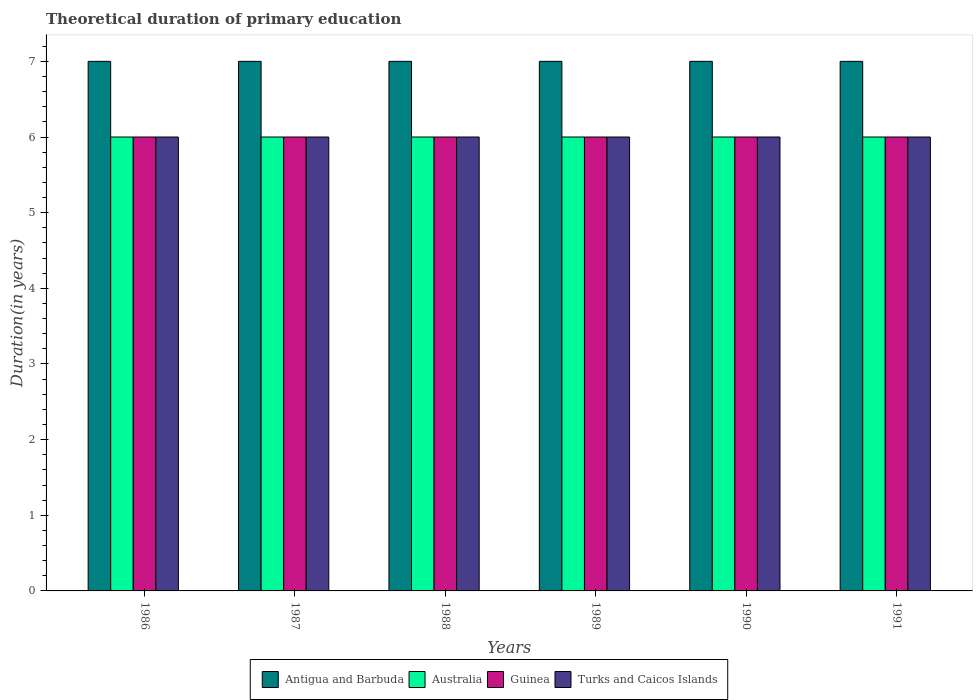How many groups of bars are there?
Ensure brevity in your answer.  6. How many bars are there on the 3rd tick from the left?
Your answer should be very brief. 4. How many bars are there on the 4th tick from the right?
Offer a very short reply. 4. What is the total theoretical duration of primary education in Turks and Caicos Islands in 1987?
Provide a short and direct response. 6. In which year was the total theoretical duration of primary education in Australia maximum?
Your answer should be compact. 1986. What is the total total theoretical duration of primary education in Turks and Caicos Islands in the graph?
Offer a very short reply. 36. What is the difference between the total theoretical duration of primary education in Antigua and Barbuda in 1987 and the total theoretical duration of primary education in Guinea in 1990?
Provide a short and direct response. 1. What is the average total theoretical duration of primary education in Guinea per year?
Your answer should be compact. 6. In the year 1990, what is the difference between the total theoretical duration of primary education in Australia and total theoretical duration of primary education in Turks and Caicos Islands?
Keep it short and to the point. 0. Is the total theoretical duration of primary education in Australia in 1988 less than that in 1990?
Provide a succinct answer. No. What is the difference between the highest and the second highest total theoretical duration of primary education in Guinea?
Keep it short and to the point. 0. What does the 4th bar from the left in 1991 represents?
Provide a short and direct response. Turks and Caicos Islands. What does the 4th bar from the right in 1988 represents?
Make the answer very short. Antigua and Barbuda. Is it the case that in every year, the sum of the total theoretical duration of primary education in Turks and Caicos Islands and total theoretical duration of primary education in Australia is greater than the total theoretical duration of primary education in Antigua and Barbuda?
Make the answer very short. Yes. How many bars are there?
Make the answer very short. 24. Does the graph contain any zero values?
Your response must be concise. No. Does the graph contain grids?
Offer a terse response. No. Where does the legend appear in the graph?
Make the answer very short. Bottom center. How are the legend labels stacked?
Offer a terse response. Horizontal. What is the title of the graph?
Your response must be concise. Theoretical duration of primary education. Does "Timor-Leste" appear as one of the legend labels in the graph?
Keep it short and to the point. No. What is the label or title of the Y-axis?
Offer a very short reply. Duration(in years). What is the Duration(in years) in Australia in 1986?
Provide a short and direct response. 6. What is the Duration(in years) in Antigua and Barbuda in 1987?
Make the answer very short. 7. What is the Duration(in years) in Australia in 1987?
Your answer should be compact. 6. What is the Duration(in years) of Antigua and Barbuda in 1989?
Your response must be concise. 7. What is the Duration(in years) of Australia in 1989?
Offer a terse response. 6. What is the Duration(in years) of Antigua and Barbuda in 1991?
Make the answer very short. 7. What is the Duration(in years) of Guinea in 1991?
Your answer should be compact. 6. What is the Duration(in years) of Turks and Caicos Islands in 1991?
Provide a succinct answer. 6. Across all years, what is the maximum Duration(in years) of Antigua and Barbuda?
Offer a terse response. 7. Across all years, what is the maximum Duration(in years) of Guinea?
Keep it short and to the point. 6. What is the total Duration(in years) of Antigua and Barbuda in the graph?
Give a very brief answer. 42. What is the total Duration(in years) of Guinea in the graph?
Make the answer very short. 36. What is the difference between the Duration(in years) of Antigua and Barbuda in 1986 and that in 1987?
Your answer should be compact. 0. What is the difference between the Duration(in years) in Australia in 1986 and that in 1987?
Give a very brief answer. 0. What is the difference between the Duration(in years) in Guinea in 1986 and that in 1987?
Make the answer very short. 0. What is the difference between the Duration(in years) in Antigua and Barbuda in 1986 and that in 1988?
Your response must be concise. 0. What is the difference between the Duration(in years) in Australia in 1986 and that in 1988?
Your response must be concise. 0. What is the difference between the Duration(in years) of Guinea in 1986 and that in 1988?
Provide a short and direct response. 0. What is the difference between the Duration(in years) of Turks and Caicos Islands in 1986 and that in 1988?
Your answer should be compact. 0. What is the difference between the Duration(in years) of Antigua and Barbuda in 1986 and that in 1989?
Your response must be concise. 0. What is the difference between the Duration(in years) in Australia in 1986 and that in 1989?
Provide a succinct answer. 0. What is the difference between the Duration(in years) of Antigua and Barbuda in 1986 and that in 1990?
Ensure brevity in your answer.  0. What is the difference between the Duration(in years) of Guinea in 1986 and that in 1991?
Offer a very short reply. 0. What is the difference between the Duration(in years) in Guinea in 1987 and that in 1988?
Your answer should be compact. 0. What is the difference between the Duration(in years) of Australia in 1987 and that in 1989?
Your answer should be very brief. 0. What is the difference between the Duration(in years) of Guinea in 1987 and that in 1989?
Make the answer very short. 0. What is the difference between the Duration(in years) in Australia in 1987 and that in 1990?
Make the answer very short. 0. What is the difference between the Duration(in years) of Turks and Caicos Islands in 1987 and that in 1990?
Your answer should be very brief. 0. What is the difference between the Duration(in years) in Australia in 1987 and that in 1991?
Your answer should be very brief. 0. What is the difference between the Duration(in years) of Australia in 1988 and that in 1989?
Make the answer very short. 0. What is the difference between the Duration(in years) of Antigua and Barbuda in 1988 and that in 1990?
Provide a short and direct response. 0. What is the difference between the Duration(in years) in Australia in 1988 and that in 1990?
Offer a terse response. 0. What is the difference between the Duration(in years) in Turks and Caicos Islands in 1988 and that in 1990?
Offer a terse response. 0. What is the difference between the Duration(in years) of Antigua and Barbuda in 1988 and that in 1991?
Your answer should be very brief. 0. What is the difference between the Duration(in years) of Guinea in 1988 and that in 1991?
Your answer should be very brief. 0. What is the difference between the Duration(in years) of Antigua and Barbuda in 1989 and that in 1990?
Your answer should be compact. 0. What is the difference between the Duration(in years) in Guinea in 1989 and that in 1990?
Your answer should be very brief. 0. What is the difference between the Duration(in years) in Antigua and Barbuda in 1989 and that in 1991?
Offer a terse response. 0. What is the difference between the Duration(in years) of Guinea in 1989 and that in 1991?
Your answer should be compact. 0. What is the difference between the Duration(in years) in Turks and Caicos Islands in 1989 and that in 1991?
Provide a succinct answer. 0. What is the difference between the Duration(in years) of Australia in 1990 and that in 1991?
Offer a very short reply. 0. What is the difference between the Duration(in years) of Turks and Caicos Islands in 1990 and that in 1991?
Your answer should be very brief. 0. What is the difference between the Duration(in years) of Australia in 1986 and the Duration(in years) of Guinea in 1987?
Keep it short and to the point. 0. What is the difference between the Duration(in years) of Australia in 1986 and the Duration(in years) of Turks and Caicos Islands in 1987?
Provide a short and direct response. 0. What is the difference between the Duration(in years) of Antigua and Barbuda in 1986 and the Duration(in years) of Guinea in 1988?
Make the answer very short. 1. What is the difference between the Duration(in years) of Antigua and Barbuda in 1986 and the Duration(in years) of Turks and Caicos Islands in 1988?
Your response must be concise. 1. What is the difference between the Duration(in years) in Guinea in 1986 and the Duration(in years) in Turks and Caicos Islands in 1988?
Ensure brevity in your answer.  0. What is the difference between the Duration(in years) of Antigua and Barbuda in 1986 and the Duration(in years) of Turks and Caicos Islands in 1989?
Your answer should be compact. 1. What is the difference between the Duration(in years) in Australia in 1986 and the Duration(in years) in Guinea in 1989?
Give a very brief answer. 0. What is the difference between the Duration(in years) in Australia in 1986 and the Duration(in years) in Guinea in 1990?
Provide a short and direct response. 0. What is the difference between the Duration(in years) in Australia in 1986 and the Duration(in years) in Turks and Caicos Islands in 1990?
Offer a terse response. 0. What is the difference between the Duration(in years) in Antigua and Barbuda in 1986 and the Duration(in years) in Turks and Caicos Islands in 1991?
Provide a short and direct response. 1. What is the difference between the Duration(in years) of Australia in 1986 and the Duration(in years) of Turks and Caicos Islands in 1991?
Provide a short and direct response. 0. What is the difference between the Duration(in years) of Guinea in 1986 and the Duration(in years) of Turks and Caicos Islands in 1991?
Keep it short and to the point. 0. What is the difference between the Duration(in years) in Antigua and Barbuda in 1987 and the Duration(in years) in Turks and Caicos Islands in 1988?
Your response must be concise. 1. What is the difference between the Duration(in years) of Australia in 1987 and the Duration(in years) of Turks and Caicos Islands in 1988?
Keep it short and to the point. 0. What is the difference between the Duration(in years) in Guinea in 1987 and the Duration(in years) in Turks and Caicos Islands in 1988?
Give a very brief answer. 0. What is the difference between the Duration(in years) of Antigua and Barbuda in 1987 and the Duration(in years) of Australia in 1989?
Your answer should be compact. 1. What is the difference between the Duration(in years) in Antigua and Barbuda in 1987 and the Duration(in years) in Turks and Caicos Islands in 1989?
Your answer should be compact. 1. What is the difference between the Duration(in years) of Australia in 1987 and the Duration(in years) of Guinea in 1989?
Offer a terse response. 0. What is the difference between the Duration(in years) in Guinea in 1987 and the Duration(in years) in Turks and Caicos Islands in 1989?
Provide a succinct answer. 0. What is the difference between the Duration(in years) in Antigua and Barbuda in 1987 and the Duration(in years) in Guinea in 1990?
Your answer should be compact. 1. What is the difference between the Duration(in years) in Guinea in 1987 and the Duration(in years) in Turks and Caicos Islands in 1990?
Your answer should be compact. 0. What is the difference between the Duration(in years) in Antigua and Barbuda in 1987 and the Duration(in years) in Australia in 1991?
Ensure brevity in your answer.  1. What is the difference between the Duration(in years) in Antigua and Barbuda in 1987 and the Duration(in years) in Guinea in 1991?
Keep it short and to the point. 1. What is the difference between the Duration(in years) of Antigua and Barbuda in 1987 and the Duration(in years) of Turks and Caicos Islands in 1991?
Your answer should be very brief. 1. What is the difference between the Duration(in years) of Australia in 1987 and the Duration(in years) of Turks and Caicos Islands in 1991?
Offer a very short reply. 0. What is the difference between the Duration(in years) in Guinea in 1987 and the Duration(in years) in Turks and Caicos Islands in 1991?
Your answer should be very brief. 0. What is the difference between the Duration(in years) of Antigua and Barbuda in 1988 and the Duration(in years) of Guinea in 1989?
Ensure brevity in your answer.  1. What is the difference between the Duration(in years) in Australia in 1988 and the Duration(in years) in Turks and Caicos Islands in 1989?
Make the answer very short. 0. What is the difference between the Duration(in years) in Guinea in 1988 and the Duration(in years) in Turks and Caicos Islands in 1989?
Offer a very short reply. 0. What is the difference between the Duration(in years) in Antigua and Barbuda in 1988 and the Duration(in years) in Turks and Caicos Islands in 1990?
Keep it short and to the point. 1. What is the difference between the Duration(in years) of Australia in 1988 and the Duration(in years) of Guinea in 1990?
Your response must be concise. 0. What is the difference between the Duration(in years) of Australia in 1988 and the Duration(in years) of Turks and Caicos Islands in 1990?
Give a very brief answer. 0. What is the difference between the Duration(in years) in Antigua and Barbuda in 1988 and the Duration(in years) in Australia in 1991?
Give a very brief answer. 1. What is the difference between the Duration(in years) of Antigua and Barbuda in 1988 and the Duration(in years) of Guinea in 1991?
Provide a succinct answer. 1. What is the difference between the Duration(in years) in Australia in 1988 and the Duration(in years) in Turks and Caicos Islands in 1991?
Your response must be concise. 0. What is the difference between the Duration(in years) of Antigua and Barbuda in 1989 and the Duration(in years) of Turks and Caicos Islands in 1990?
Make the answer very short. 1. What is the difference between the Duration(in years) in Australia in 1989 and the Duration(in years) in Guinea in 1990?
Provide a short and direct response. 0. What is the difference between the Duration(in years) in Antigua and Barbuda in 1989 and the Duration(in years) in Guinea in 1991?
Provide a succinct answer. 1. What is the difference between the Duration(in years) in Australia in 1989 and the Duration(in years) in Guinea in 1991?
Offer a terse response. 0. What is the difference between the Duration(in years) in Guinea in 1989 and the Duration(in years) in Turks and Caicos Islands in 1991?
Make the answer very short. 0. What is the difference between the Duration(in years) in Antigua and Barbuda in 1990 and the Duration(in years) in Turks and Caicos Islands in 1991?
Keep it short and to the point. 1. What is the difference between the Duration(in years) in Australia in 1990 and the Duration(in years) in Guinea in 1991?
Provide a short and direct response. 0. What is the difference between the Duration(in years) of Guinea in 1990 and the Duration(in years) of Turks and Caicos Islands in 1991?
Provide a short and direct response. 0. What is the average Duration(in years) in Antigua and Barbuda per year?
Offer a terse response. 7. What is the average Duration(in years) in Australia per year?
Offer a very short reply. 6. What is the average Duration(in years) in Guinea per year?
Keep it short and to the point. 6. What is the average Duration(in years) of Turks and Caicos Islands per year?
Provide a short and direct response. 6. In the year 1986, what is the difference between the Duration(in years) in Antigua and Barbuda and Duration(in years) in Australia?
Offer a terse response. 1. In the year 1986, what is the difference between the Duration(in years) of Antigua and Barbuda and Duration(in years) of Guinea?
Keep it short and to the point. 1. In the year 1986, what is the difference between the Duration(in years) in Antigua and Barbuda and Duration(in years) in Turks and Caicos Islands?
Give a very brief answer. 1. In the year 1987, what is the difference between the Duration(in years) of Antigua and Barbuda and Duration(in years) of Guinea?
Ensure brevity in your answer.  1. In the year 1987, what is the difference between the Duration(in years) of Australia and Duration(in years) of Guinea?
Your response must be concise. 0. In the year 1987, what is the difference between the Duration(in years) of Guinea and Duration(in years) of Turks and Caicos Islands?
Make the answer very short. 0. In the year 1988, what is the difference between the Duration(in years) of Antigua and Barbuda and Duration(in years) of Turks and Caicos Islands?
Your answer should be compact. 1. In the year 1989, what is the difference between the Duration(in years) in Antigua and Barbuda and Duration(in years) in Guinea?
Ensure brevity in your answer.  1. In the year 1989, what is the difference between the Duration(in years) in Australia and Duration(in years) in Turks and Caicos Islands?
Offer a terse response. 0. In the year 1989, what is the difference between the Duration(in years) in Guinea and Duration(in years) in Turks and Caicos Islands?
Ensure brevity in your answer.  0. In the year 1990, what is the difference between the Duration(in years) of Antigua and Barbuda and Duration(in years) of Australia?
Your response must be concise. 1. In the year 1990, what is the difference between the Duration(in years) in Antigua and Barbuda and Duration(in years) in Guinea?
Provide a succinct answer. 1. In the year 1990, what is the difference between the Duration(in years) in Australia and Duration(in years) in Guinea?
Your answer should be compact. 0. In the year 1990, what is the difference between the Duration(in years) of Australia and Duration(in years) of Turks and Caicos Islands?
Give a very brief answer. 0. In the year 1991, what is the difference between the Duration(in years) of Australia and Duration(in years) of Turks and Caicos Islands?
Keep it short and to the point. 0. What is the ratio of the Duration(in years) of Australia in 1986 to that in 1987?
Your answer should be very brief. 1. What is the ratio of the Duration(in years) of Guinea in 1986 to that in 1987?
Offer a very short reply. 1. What is the ratio of the Duration(in years) of Turks and Caicos Islands in 1986 to that in 1987?
Provide a short and direct response. 1. What is the ratio of the Duration(in years) in Guinea in 1986 to that in 1988?
Your answer should be very brief. 1. What is the ratio of the Duration(in years) in Turks and Caicos Islands in 1986 to that in 1988?
Your answer should be compact. 1. What is the ratio of the Duration(in years) in Australia in 1986 to that in 1989?
Your answer should be very brief. 1. What is the ratio of the Duration(in years) in Guinea in 1986 to that in 1989?
Your response must be concise. 1. What is the ratio of the Duration(in years) in Turks and Caicos Islands in 1986 to that in 1989?
Offer a very short reply. 1. What is the ratio of the Duration(in years) in Australia in 1986 to that in 1990?
Provide a short and direct response. 1. What is the ratio of the Duration(in years) of Antigua and Barbuda in 1986 to that in 1991?
Make the answer very short. 1. What is the ratio of the Duration(in years) of Turks and Caicos Islands in 1986 to that in 1991?
Your answer should be very brief. 1. What is the ratio of the Duration(in years) in Australia in 1987 to that in 1988?
Provide a short and direct response. 1. What is the ratio of the Duration(in years) in Guinea in 1987 to that in 1989?
Your response must be concise. 1. What is the ratio of the Duration(in years) of Antigua and Barbuda in 1987 to that in 1990?
Provide a short and direct response. 1. What is the ratio of the Duration(in years) in Turks and Caicos Islands in 1987 to that in 1990?
Make the answer very short. 1. What is the ratio of the Duration(in years) of Guinea in 1988 to that in 1989?
Make the answer very short. 1. What is the ratio of the Duration(in years) of Antigua and Barbuda in 1988 to that in 1990?
Provide a succinct answer. 1. What is the ratio of the Duration(in years) in Guinea in 1988 to that in 1990?
Give a very brief answer. 1. What is the ratio of the Duration(in years) in Turks and Caicos Islands in 1988 to that in 1990?
Your answer should be compact. 1. What is the ratio of the Duration(in years) in Antigua and Barbuda in 1988 to that in 1991?
Make the answer very short. 1. What is the ratio of the Duration(in years) of Australia in 1988 to that in 1991?
Your response must be concise. 1. What is the ratio of the Duration(in years) of Guinea in 1988 to that in 1991?
Give a very brief answer. 1. What is the ratio of the Duration(in years) of Turks and Caicos Islands in 1988 to that in 1991?
Your response must be concise. 1. What is the ratio of the Duration(in years) of Australia in 1989 to that in 1990?
Offer a very short reply. 1. What is the ratio of the Duration(in years) in Guinea in 1989 to that in 1990?
Give a very brief answer. 1. What is the ratio of the Duration(in years) in Turks and Caicos Islands in 1989 to that in 1990?
Your answer should be compact. 1. What is the ratio of the Duration(in years) in Antigua and Barbuda in 1989 to that in 1991?
Offer a very short reply. 1. What is the ratio of the Duration(in years) of Australia in 1989 to that in 1991?
Keep it short and to the point. 1. What is the ratio of the Duration(in years) of Turks and Caicos Islands in 1989 to that in 1991?
Your answer should be compact. 1. What is the ratio of the Duration(in years) of Australia in 1990 to that in 1991?
Make the answer very short. 1. What is the ratio of the Duration(in years) in Guinea in 1990 to that in 1991?
Keep it short and to the point. 1. What is the ratio of the Duration(in years) in Turks and Caicos Islands in 1990 to that in 1991?
Offer a very short reply. 1. What is the difference between the highest and the second highest Duration(in years) of Antigua and Barbuda?
Provide a succinct answer. 0. What is the difference between the highest and the second highest Duration(in years) of Guinea?
Give a very brief answer. 0. What is the difference between the highest and the second highest Duration(in years) of Turks and Caicos Islands?
Keep it short and to the point. 0. What is the difference between the highest and the lowest Duration(in years) in Antigua and Barbuda?
Your answer should be very brief. 0. What is the difference between the highest and the lowest Duration(in years) in Australia?
Provide a short and direct response. 0. 